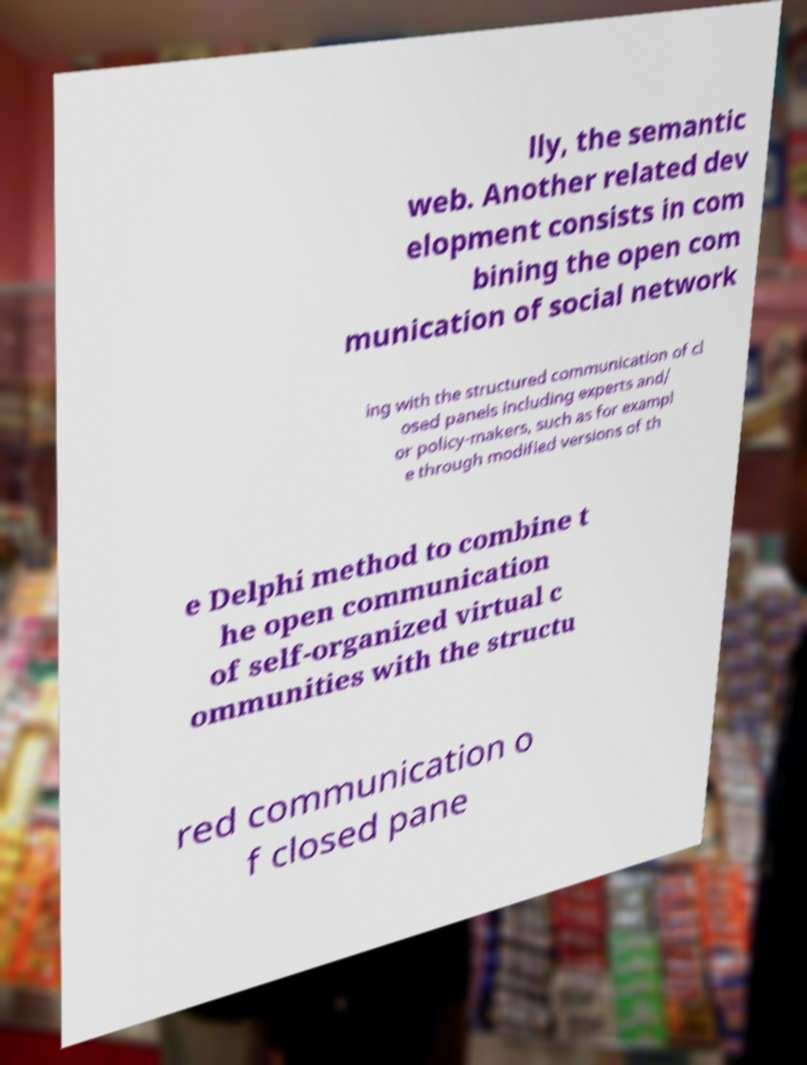Can you accurately transcribe the text from the provided image for me? lly, the semantic web. Another related dev elopment consists in com bining the open com munication of social network ing with the structured communication of cl osed panels including experts and/ or policy-makers, such as for exampl e through modified versions of th e Delphi method to combine t he open communication of self-organized virtual c ommunities with the structu red communication o f closed pane 